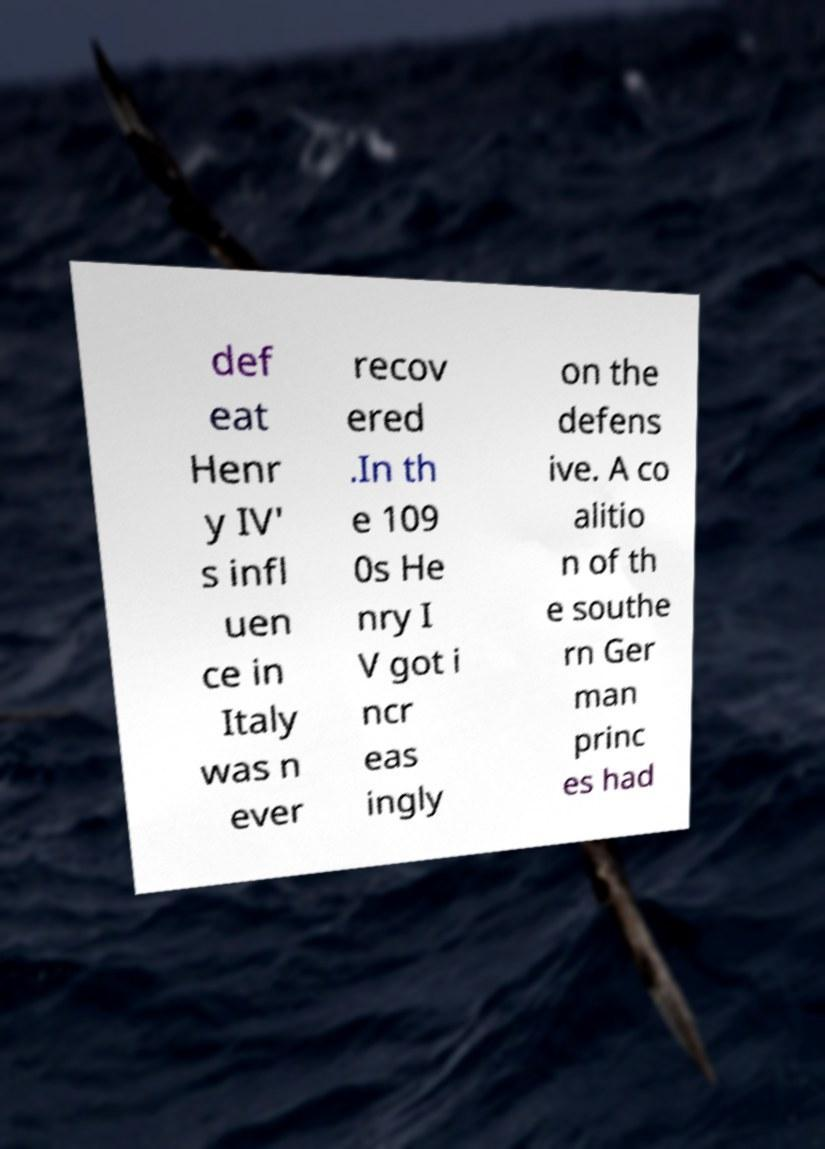Can you accurately transcribe the text from the provided image for me? def eat Henr y IV' s infl uen ce in Italy was n ever recov ered .In th e 109 0s He nry I V got i ncr eas ingly on the defens ive. A co alitio n of th e southe rn Ger man princ es had 